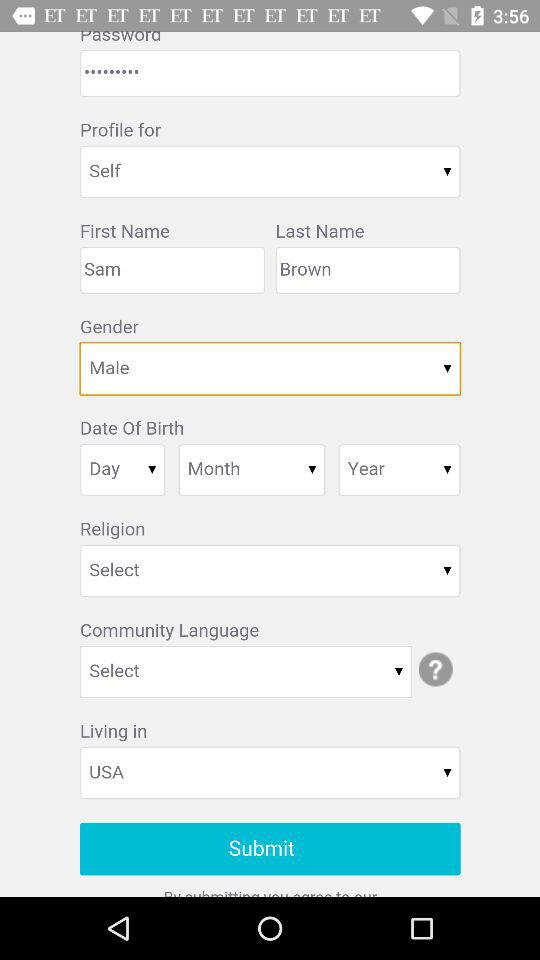What is the gender of the user? The gender of the user is male. 